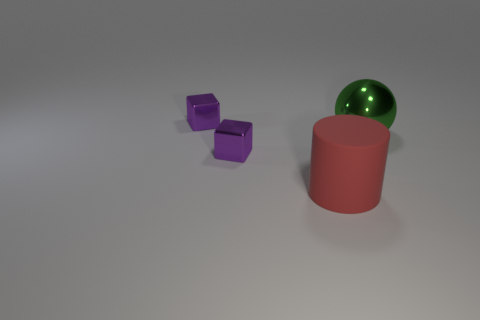Add 2 purple matte cylinders. How many objects exist? 6 Add 3 big purple rubber cubes. How many big purple rubber cubes exist? 3 Subtract 0 yellow cubes. How many objects are left? 4 Subtract all spheres. How many objects are left? 3 Subtract all blue blocks. Subtract all brown cylinders. How many blocks are left? 2 Subtract all red balls. How many green cylinders are left? 0 Subtract all large yellow shiny blocks. Subtract all tiny purple shiny cubes. How many objects are left? 2 Add 3 tiny purple blocks. How many tiny purple blocks are left? 5 